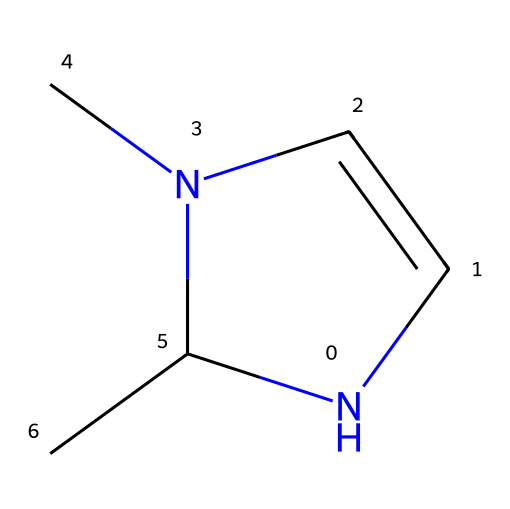What is the main element present in the ring of the molecule? The ring consists of carbon and nitrogen atoms, with the nitrogen atom being the primary heteroatom in this N-heterocyclic structure.
Answer: nitrogen How many carbon atoms are in the structure? The SMILES representation indicates there are five carbon atoms in total, as evidenced by the "C" symbols in the linear representation.
Answer: 5 What is the hybridization of the nitrogen atom in the carbene? The nitrogen in an N-heterocyclic carbene typically has a sp2 hybridization due to its bonding in a cyclic structure, allowing resonance and stability.
Answer: sp2 Is this molecule a stable carbene? The structure indicates that it may be stabilized by resonance, typical of N-heterocyclic carbenes, which enhances their stability compared to traditional carbenes.
Answer: yes What type of reaction is this N-heterocyclic carbene primarily used for? N-heterocyclic carbenes are commonly used for metal-free polymerization reactions, allowing for the formation of polymers without the need for metal catalysts.
Answer: polymerization How many double bonds are present in the structure? The structure shows one double bond between the carbon and nitrogen atoms in the ring; thus, there is one double bond visible.
Answer: 1 